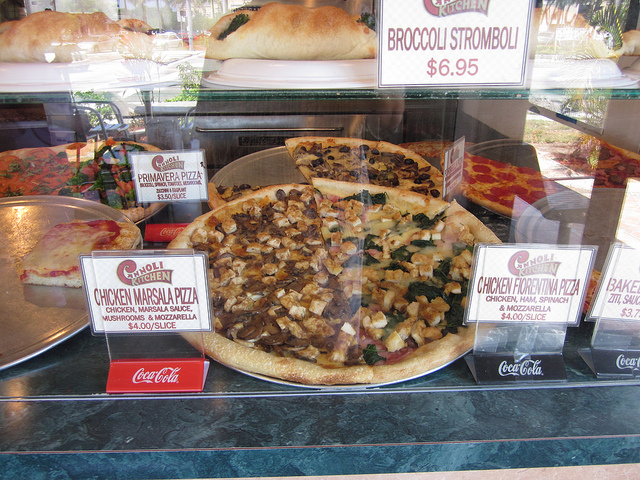Identify the text displayed in this image. BROCCOLI STROMBOLI 6.95 PIZZA MARSALA Coca-Cola SLICE $4.00 CHICKEN MOZZARELLA PIZZA CHICKEN KITCHEN $3.50 PRIMAVERA Coca-Cola Coca BAKE & $4.00/ 5UCE MOZZARELLA SPINACH HALL CHICKEN FIORENINA CHICKEN Cannoli KITCHEN 